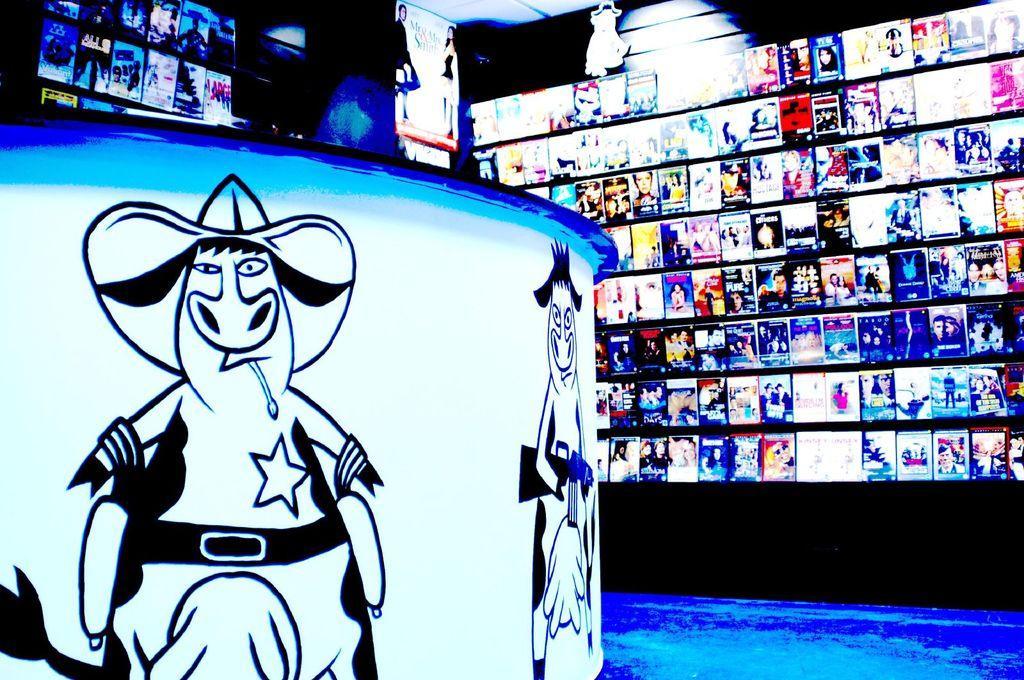In one or two sentences, can you explain what this image depicts? On the left side of the image there is a table and we can see paintings on the table. In the background there are posters placed on the wall and we can see a light. 